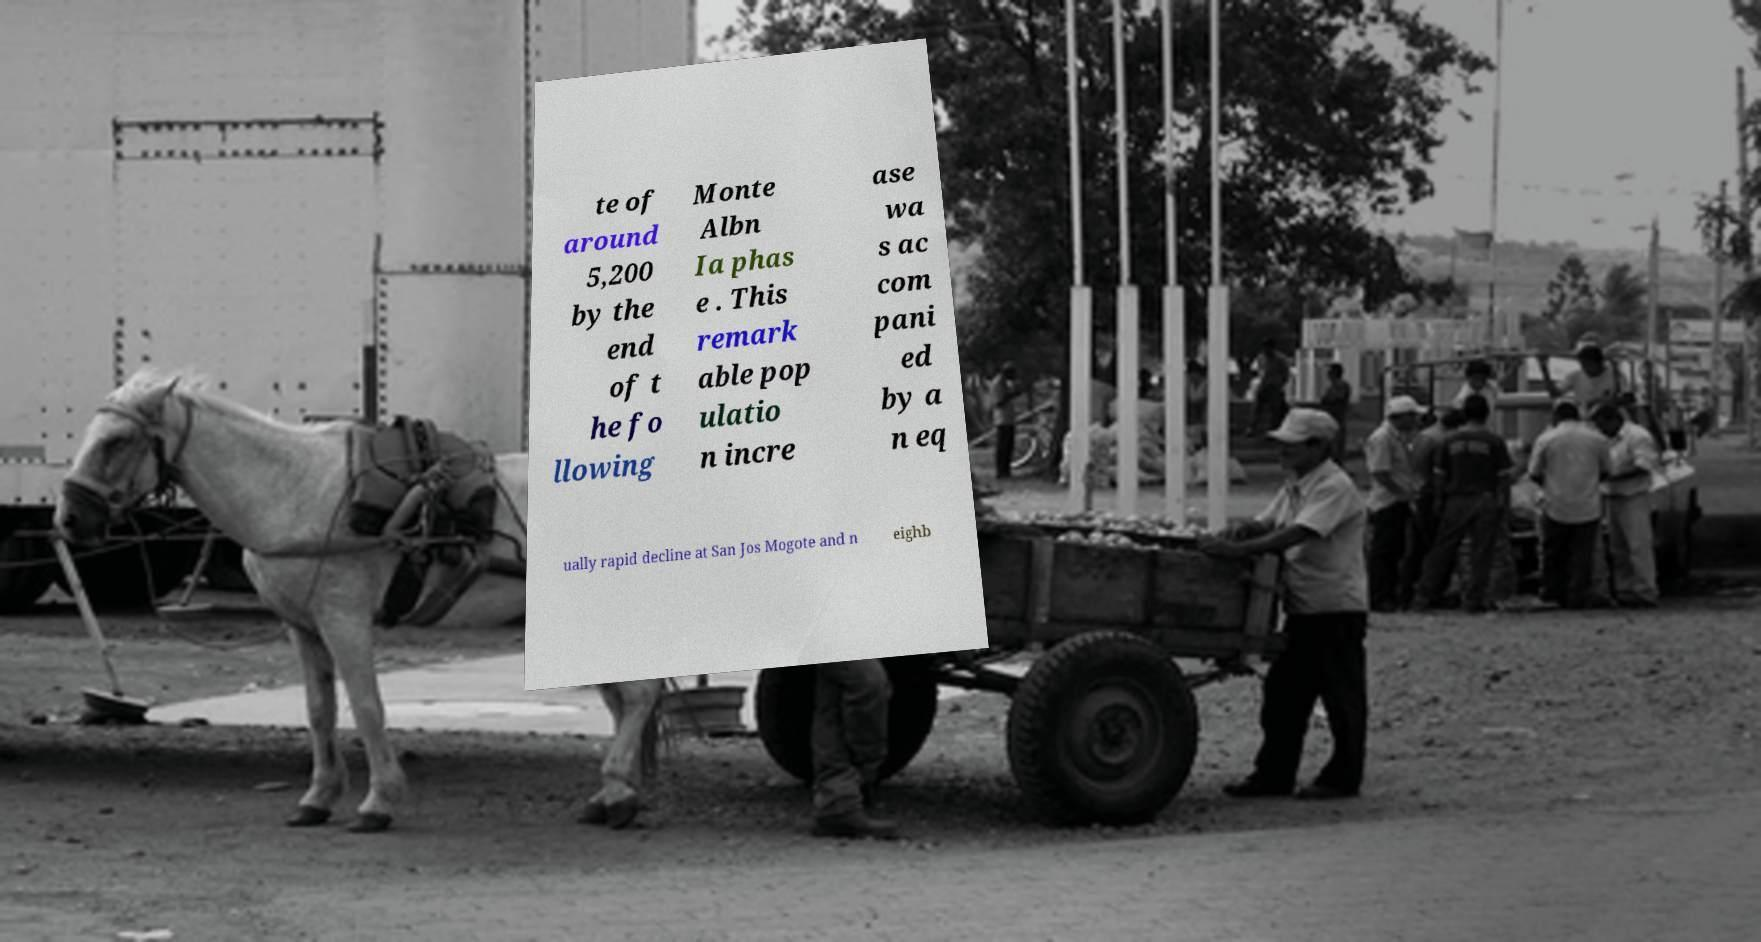Please identify and transcribe the text found in this image. te of around 5,200 by the end of t he fo llowing Monte Albn Ia phas e . This remark able pop ulatio n incre ase wa s ac com pani ed by a n eq ually rapid decline at San Jos Mogote and n eighb 